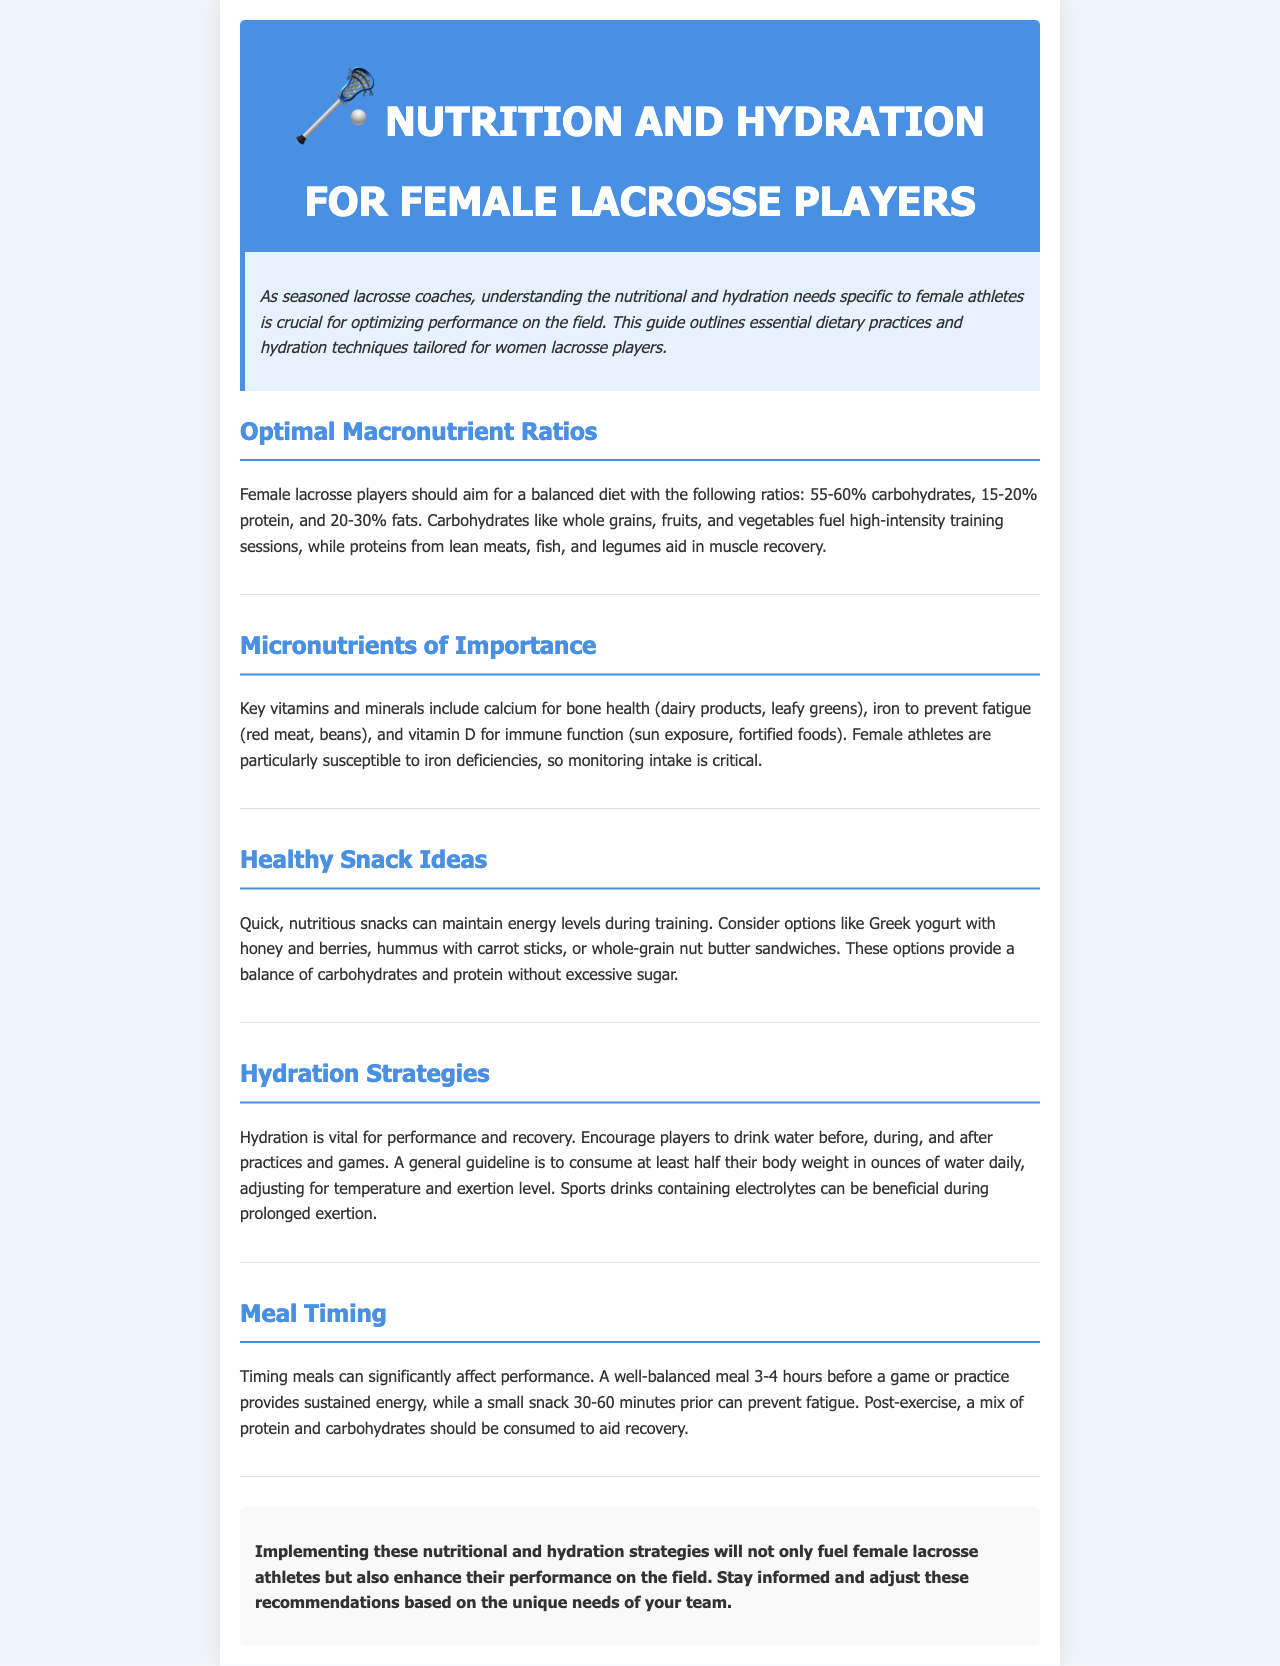What is the optimal carbohydrate percentage for female lacrosse players? The document states that female lacrosse players should aim for 55-60% carbohydrates in their diet.
Answer: 55-60% Which micronutrient is particularly important for preventing fatigue? The document mentions iron as a key micronutrient to prevent fatigue, especially for female athletes.
Answer: Iron What is a recommended snack option mentioned in the document? The document suggests Greek yogurt with honey and berries as a nutritious snack option.
Answer: Greek yogurt with honey and berries How much water should players drink daily? The guideline in the document states players should consume at least half their body weight in ounces of water daily.
Answer: Half their body weight in ounces What should be consumed post-exercise for recovery? The document states that a mix of protein and carbohydrates should be consumed post-exercise to aid recovery.
Answer: Protein and carbohydrates What is the role of calcium mentioned in the document? Calcium is highlighted in the document for its role in maintaining bone health.
Answer: Bone health What food source is recommended for vitamin D? The document mentions sun exposure and fortified foods as sources of vitamin D.
Answer: Sun exposure, fortified foods What is the suggested snack timing before practice? The document recommends a small snack 30-60 minutes prior to practice.
Answer: 30-60 minutes What is the focus of this newsletter? This newsletter is focused on the nutritional and hydration needs specific to female lacrosse players.
Answer: Nutritional and hydration needs 